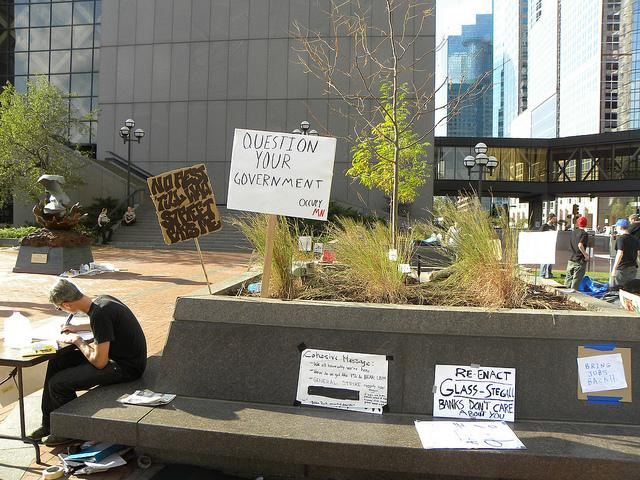What is the man participating in? protest 